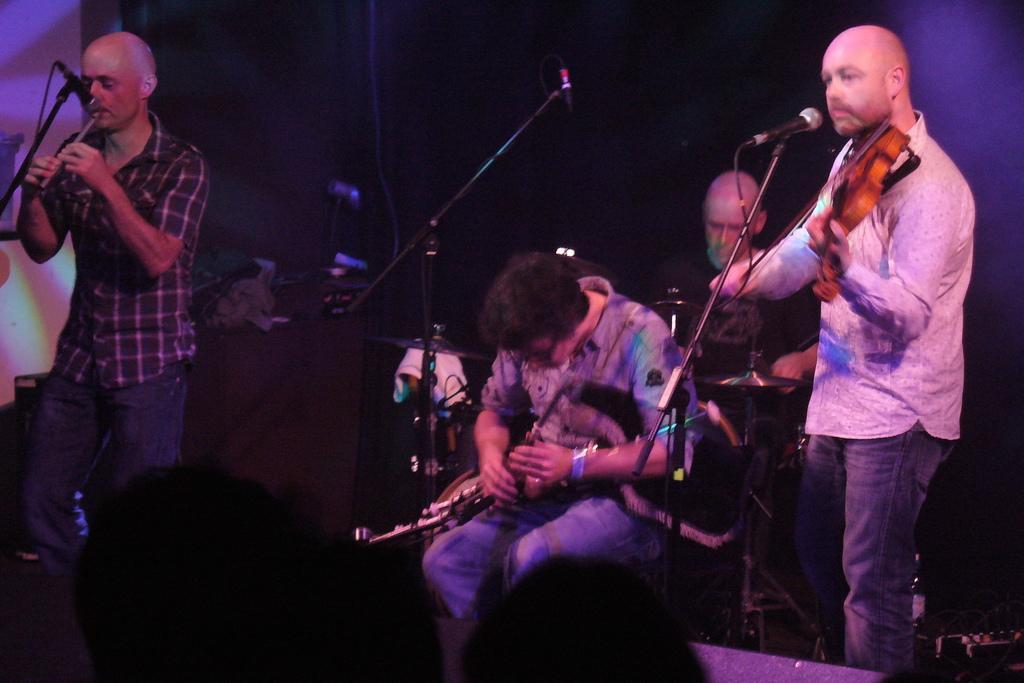In one or two sentences, can you explain what this image depicts? In this image there are two people sitting on chairs and two are standing, they are playing musical instruments, in front of them there are mikes, in the background it is dark. 